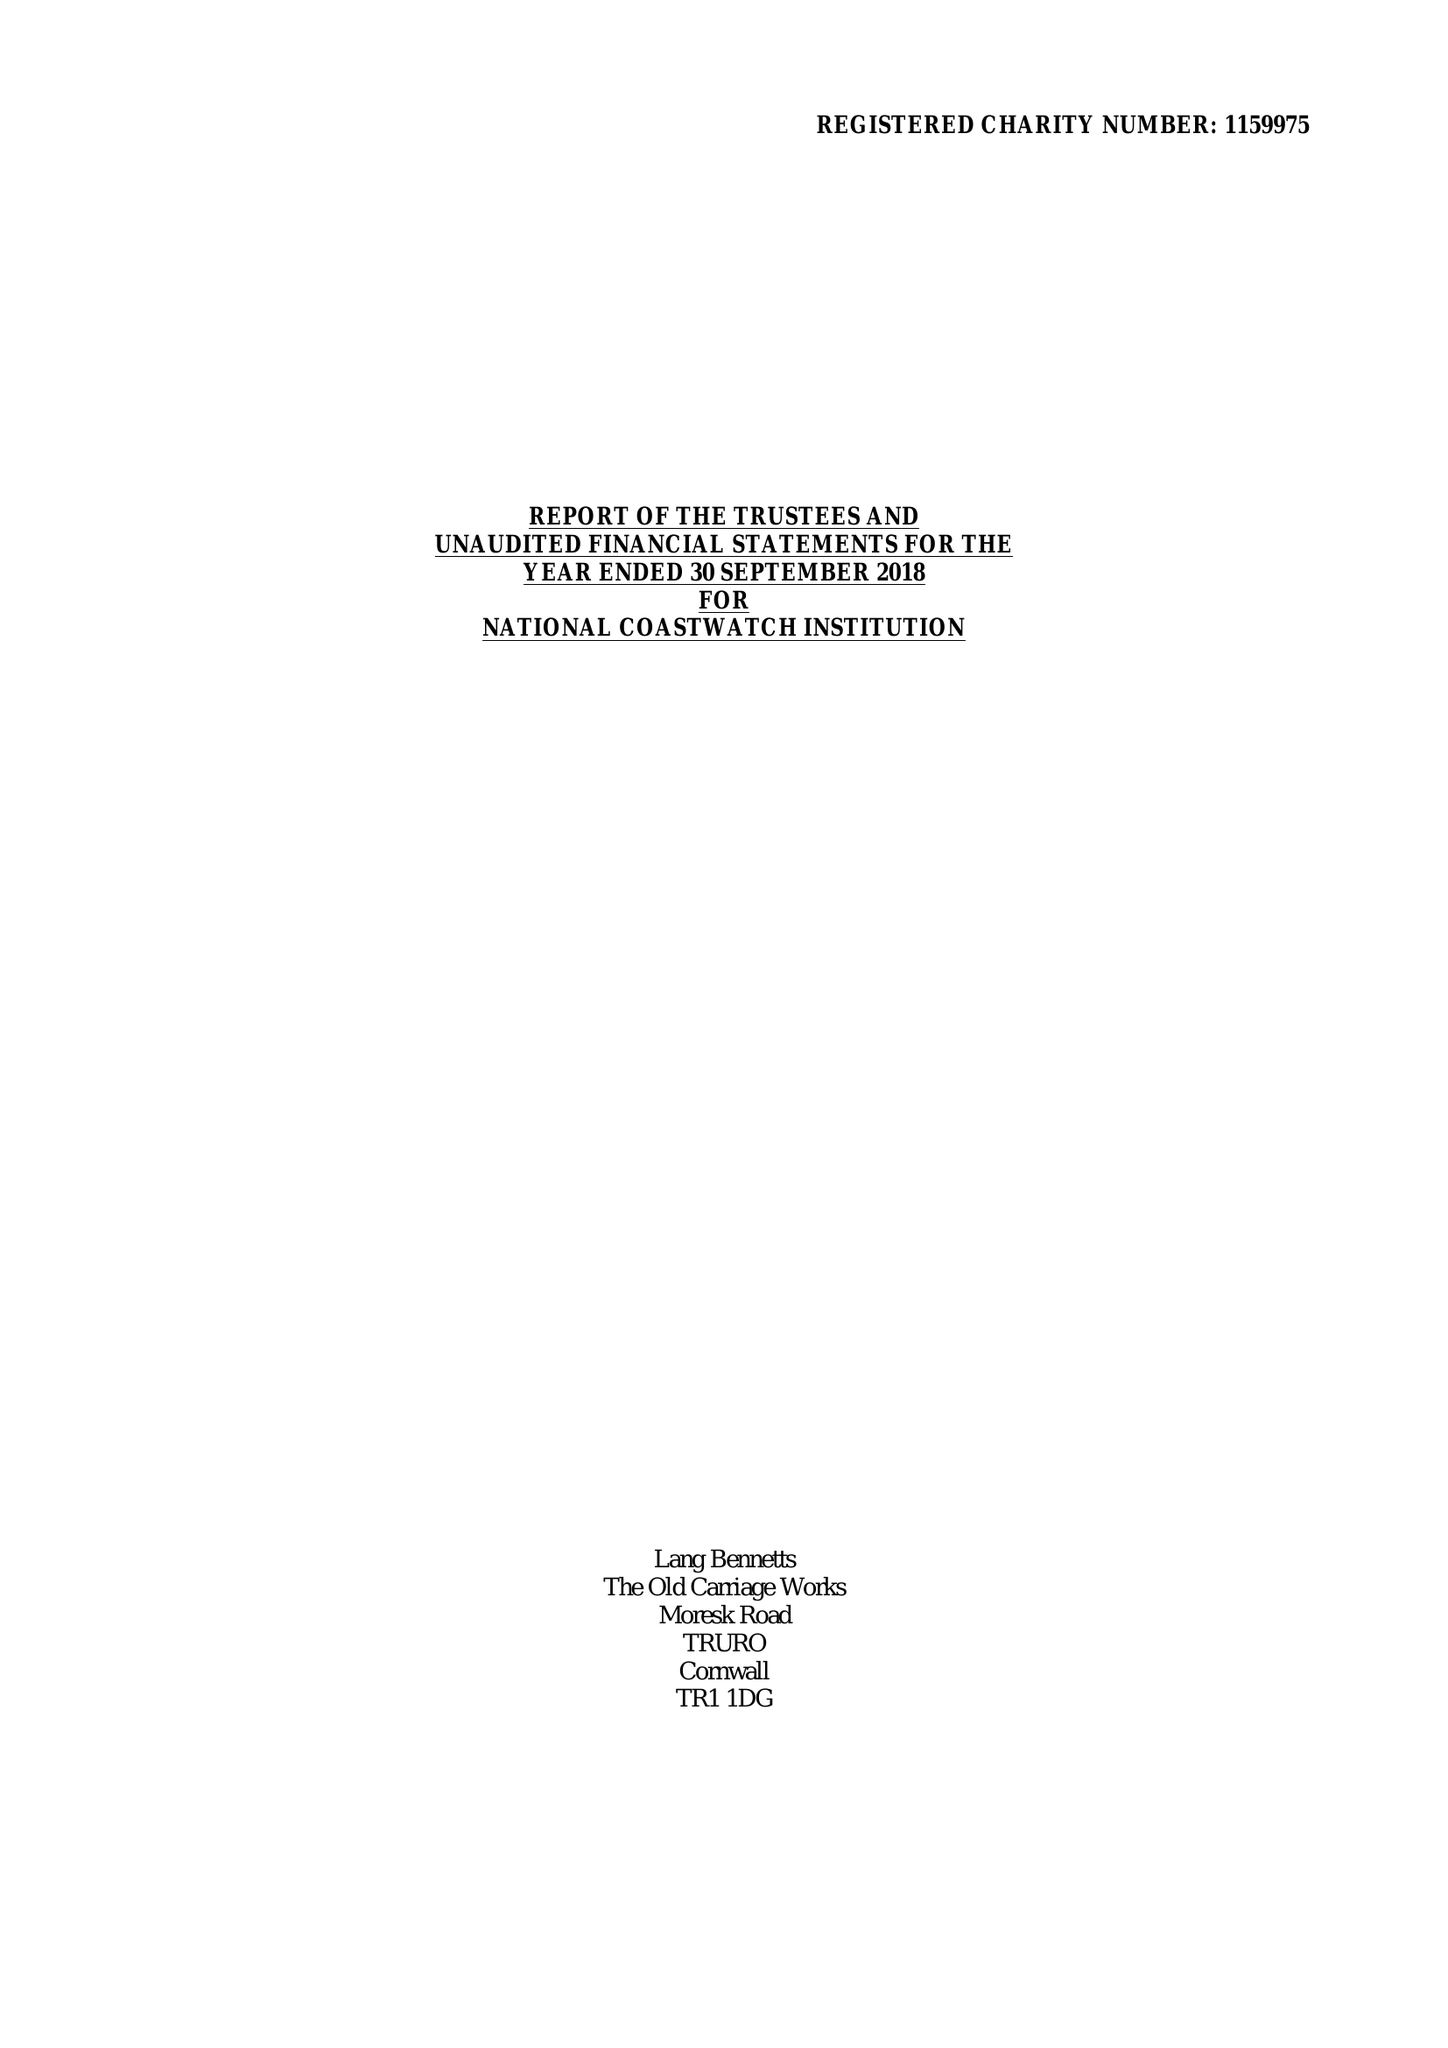What is the value for the address__street_line?
Answer the question using a single word or phrase. 17 DEAN STREET 